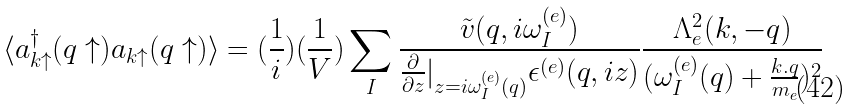<formula> <loc_0><loc_0><loc_500><loc_500>\langle a ^ { \dagger } _ { { k } \uparrow } ( { q } \uparrow ) a _ { { k } \uparrow } ( { q } \uparrow ) \rangle = ( \frac { 1 } { i } ) ( \frac { 1 } { V } ) \sum _ { I } \frac { { \tilde { v } } ( { q } , i \omega ^ { ( e ) } _ { I } ) } { \frac { \partial } { \partial z } | _ { z = i \omega ^ { ( e ) } _ { I } ( { q } ) } \epsilon ^ { ( e ) } ( { q } , i z ) } \frac { \Lambda ^ { 2 } _ { e } ( { k } , - { q } ) } { ( \omega ^ { ( e ) } _ { I } ( { q } ) + \frac { k . q } { m _ { e } } ) ^ { 2 } }</formula> 